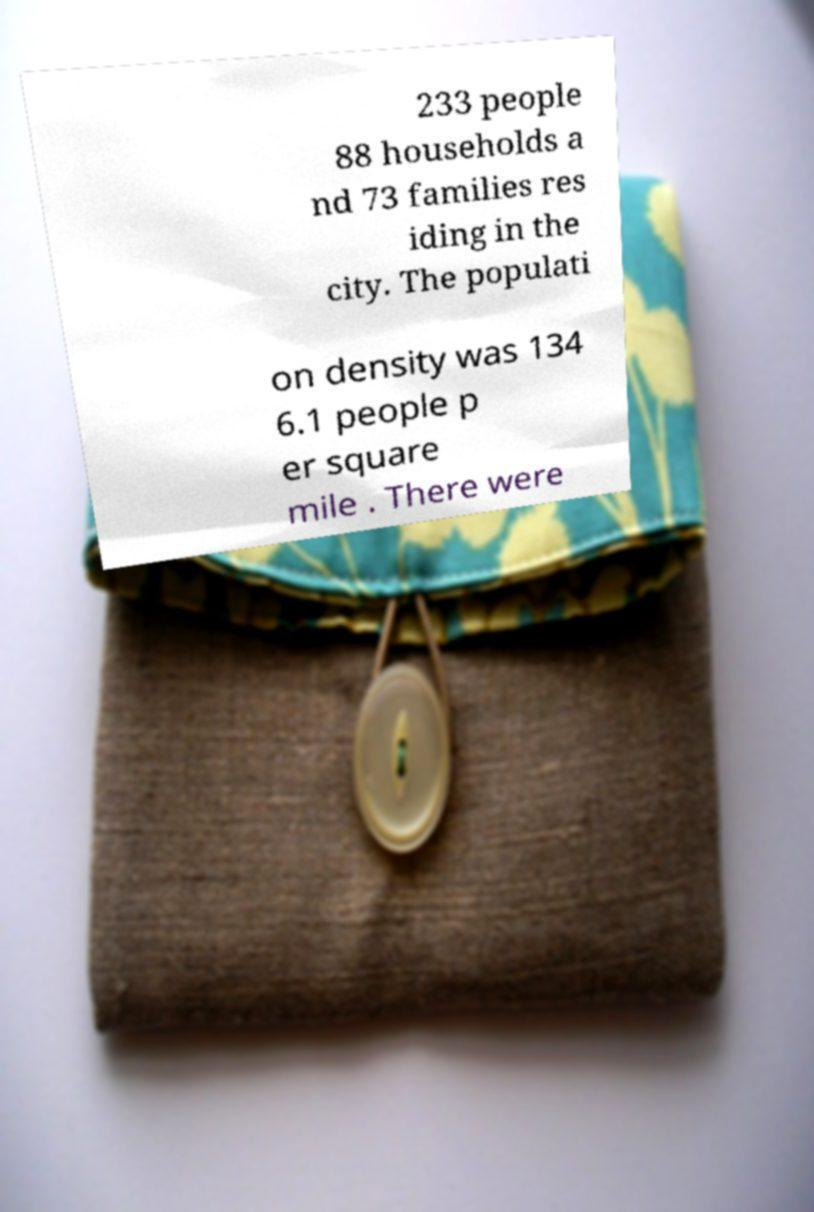Please identify and transcribe the text found in this image. 233 people 88 households a nd 73 families res iding in the city. The populati on density was 134 6.1 people p er square mile . There were 